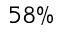Convert formula to latex. <formula><loc_0><loc_0><loc_500><loc_500>5 8 \%</formula> 